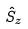<formula> <loc_0><loc_0><loc_500><loc_500>\hat { S } _ { z }</formula> 